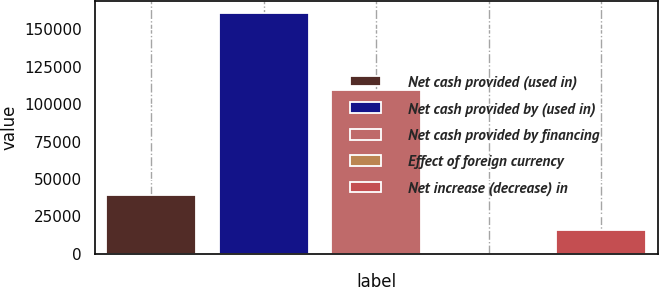Convert chart. <chart><loc_0><loc_0><loc_500><loc_500><bar_chart><fcel>Net cash provided (used in)<fcel>Net cash provided by (used in)<fcel>Net cash provided by financing<fcel>Effect of foreign currency<fcel>Net increase (decrease) in<nl><fcel>39000<fcel>160735<fcel>109296<fcel>3<fcel>16076.2<nl></chart> 